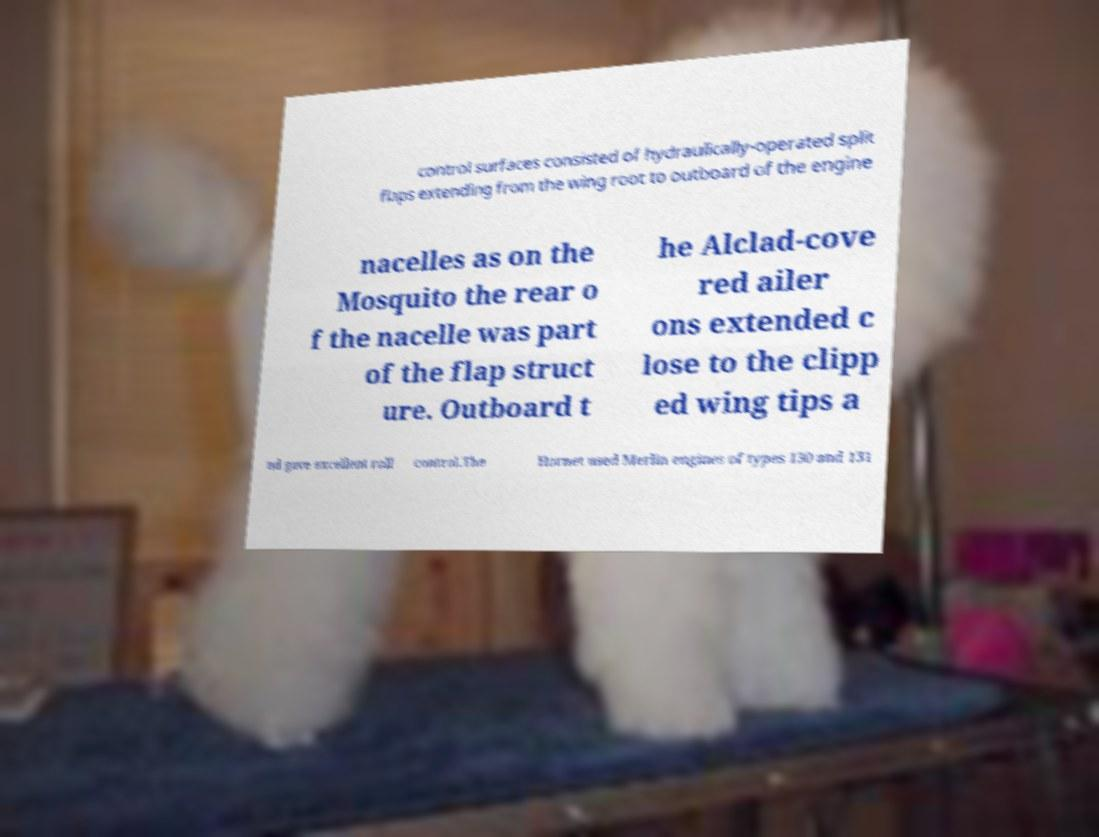What messages or text are displayed in this image? I need them in a readable, typed format. control surfaces consisted of hydraulically-operated split flaps extending from the wing root to outboard of the engine nacelles as on the Mosquito the rear o f the nacelle was part of the flap struct ure. Outboard t he Alclad-cove red ailer ons extended c lose to the clipp ed wing tips a nd gave excellent roll control.The Hornet used Merlin engines of types 130 and 131 